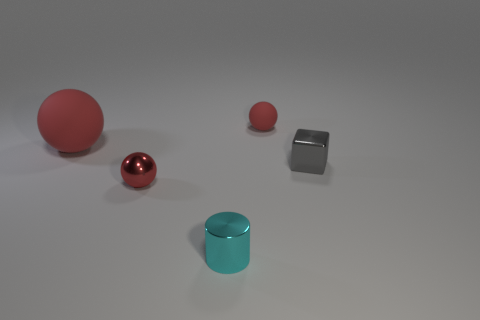Subtract all rubber spheres. How many spheres are left? 1 Subtract 1 balls. How many balls are left? 2 Add 2 big objects. How many objects exist? 7 Subtract 0 blue cylinders. How many objects are left? 5 Subtract all spheres. How many objects are left? 2 Subtract all blue balls. Subtract all cyan cubes. How many balls are left? 3 Subtract all spheres. Subtract all big blue spheres. How many objects are left? 2 Add 4 red rubber balls. How many red rubber balls are left? 6 Add 3 small red rubber balls. How many small red rubber balls exist? 4 